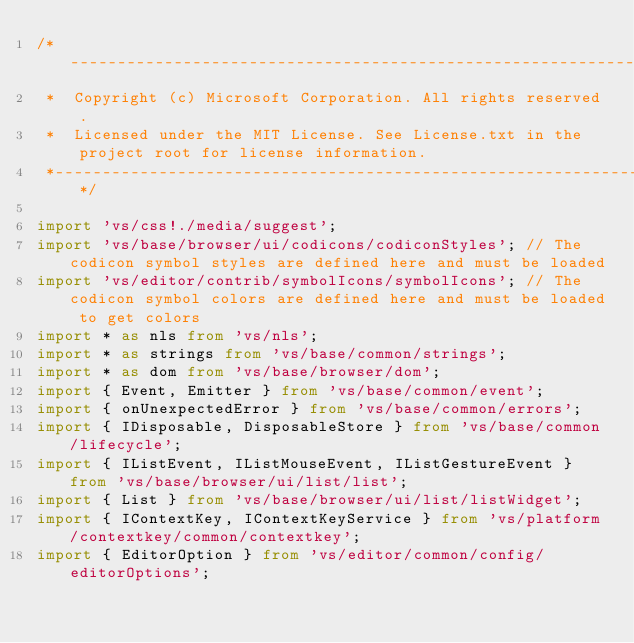Convert code to text. <code><loc_0><loc_0><loc_500><loc_500><_TypeScript_>/*---------------------------------------------------------------------------------------------
 *  Copyright (c) Microsoft Corporation. All rights reserved.
 *  Licensed under the MIT License. See License.txt in the project root for license information.
 *--------------------------------------------------------------------------------------------*/

import 'vs/css!./media/suggest';
import 'vs/base/browser/ui/codicons/codiconStyles'; // The codicon symbol styles are defined here and must be loaded
import 'vs/editor/contrib/symbolIcons/symbolIcons'; // The codicon symbol colors are defined here and must be loaded to get colors
import * as nls from 'vs/nls';
import * as strings from 'vs/base/common/strings';
import * as dom from 'vs/base/browser/dom';
import { Event, Emitter } from 'vs/base/common/event';
import { onUnexpectedError } from 'vs/base/common/errors';
import { IDisposable, DisposableStore } from 'vs/base/common/lifecycle';
import { IListEvent, IListMouseEvent, IListGestureEvent } from 'vs/base/browser/ui/list/list';
import { List } from 'vs/base/browser/ui/list/listWidget';
import { IContextKey, IContextKeyService } from 'vs/platform/contextkey/common/contextkey';
import { EditorOption } from 'vs/editor/common/config/editorOptions';</code> 